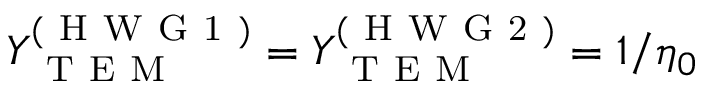<formula> <loc_0><loc_0><loc_500><loc_500>Y _ { T E M } ^ { ( H W G 1 ) } = Y _ { T E M } ^ { ( H W G 2 ) } = 1 / \eta _ { 0 }</formula> 